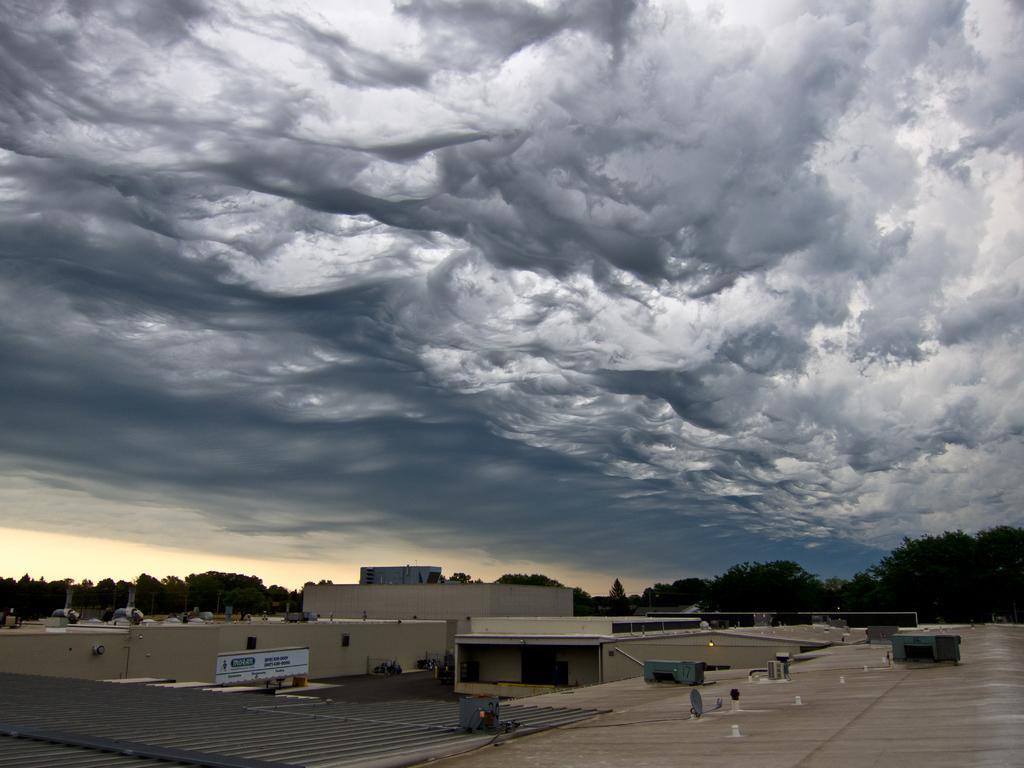In one or two sentences, can you explain what this image depicts? In this image, we can see buildings and trees. There are clouds in the sky. 